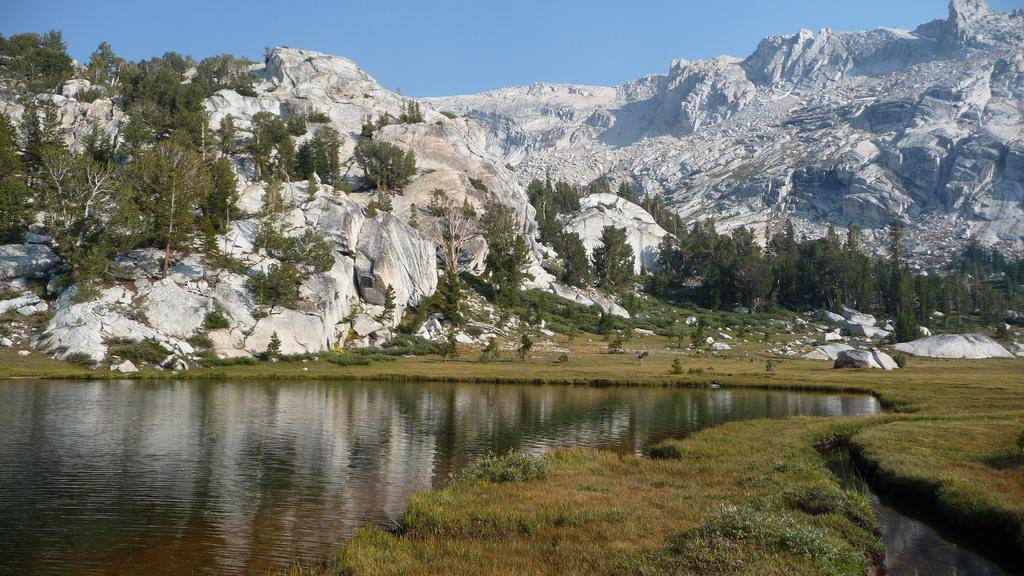What type of vegetation can be seen in the image? There is grass in the image. What natural element is also present in the image? There is water in the image. What other natural features can be seen in the image? There are trees and hills in the image. Can you describe the gate that is blocking the path in the image? There is no gate present in the image; it features grass, water, trees, and hills. How does the earthquake affect the landscape in the image? There is no earthquake depicted in the image; it shows a natural landscape with grass, water, trees, and hills. 